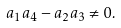Convert formula to latex. <formula><loc_0><loc_0><loc_500><loc_500>a _ { 1 } a _ { 4 } - a _ { 2 } a _ { 3 } \neq 0 .</formula> 